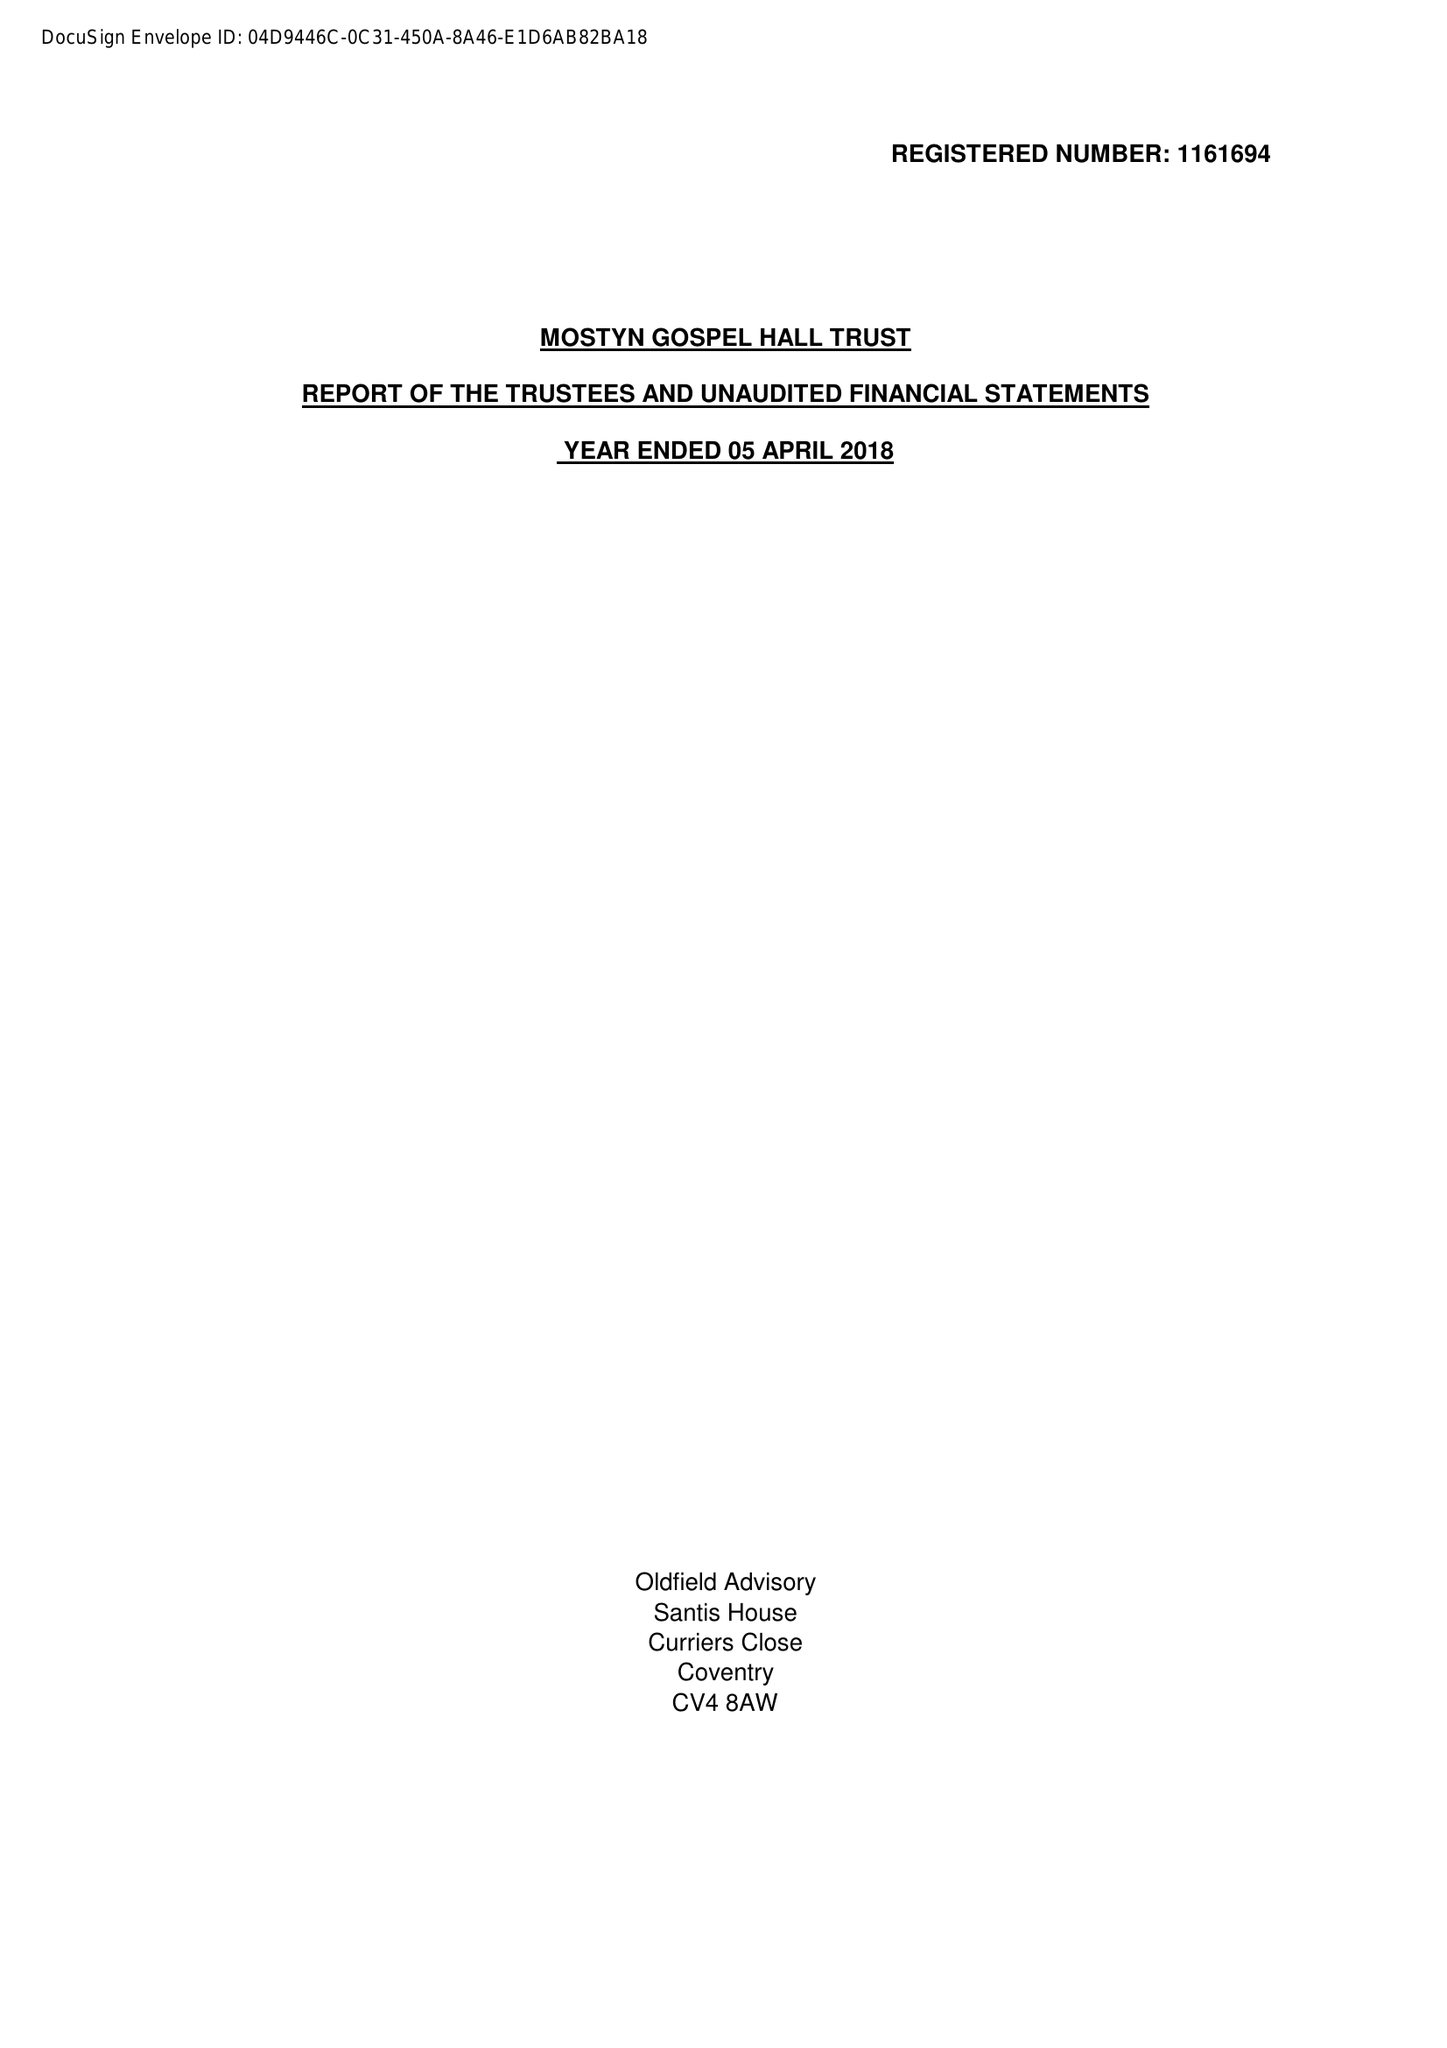What is the value for the income_annually_in_british_pounds?
Answer the question using a single word or phrase. 36355.00 